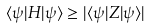<formula> <loc_0><loc_0><loc_500><loc_500>\langle \psi | H | \psi \rangle \geq | \langle \psi | Z | \psi \rangle |</formula> 